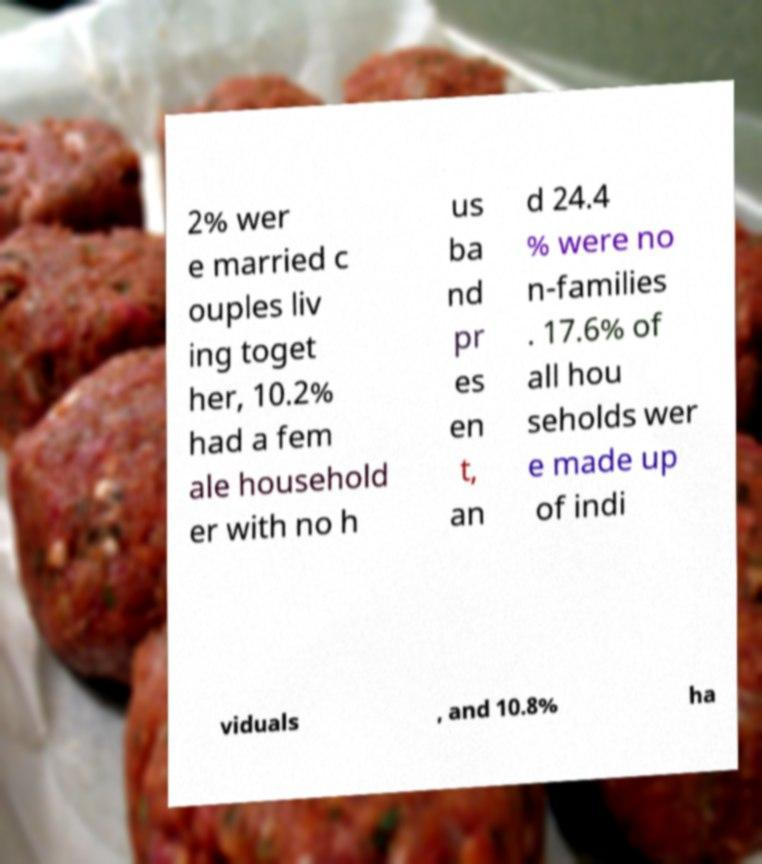For documentation purposes, I need the text within this image transcribed. Could you provide that? 2% wer e married c ouples liv ing toget her, 10.2% had a fem ale household er with no h us ba nd pr es en t, an d 24.4 % were no n-families . 17.6% of all hou seholds wer e made up of indi viduals , and 10.8% ha 